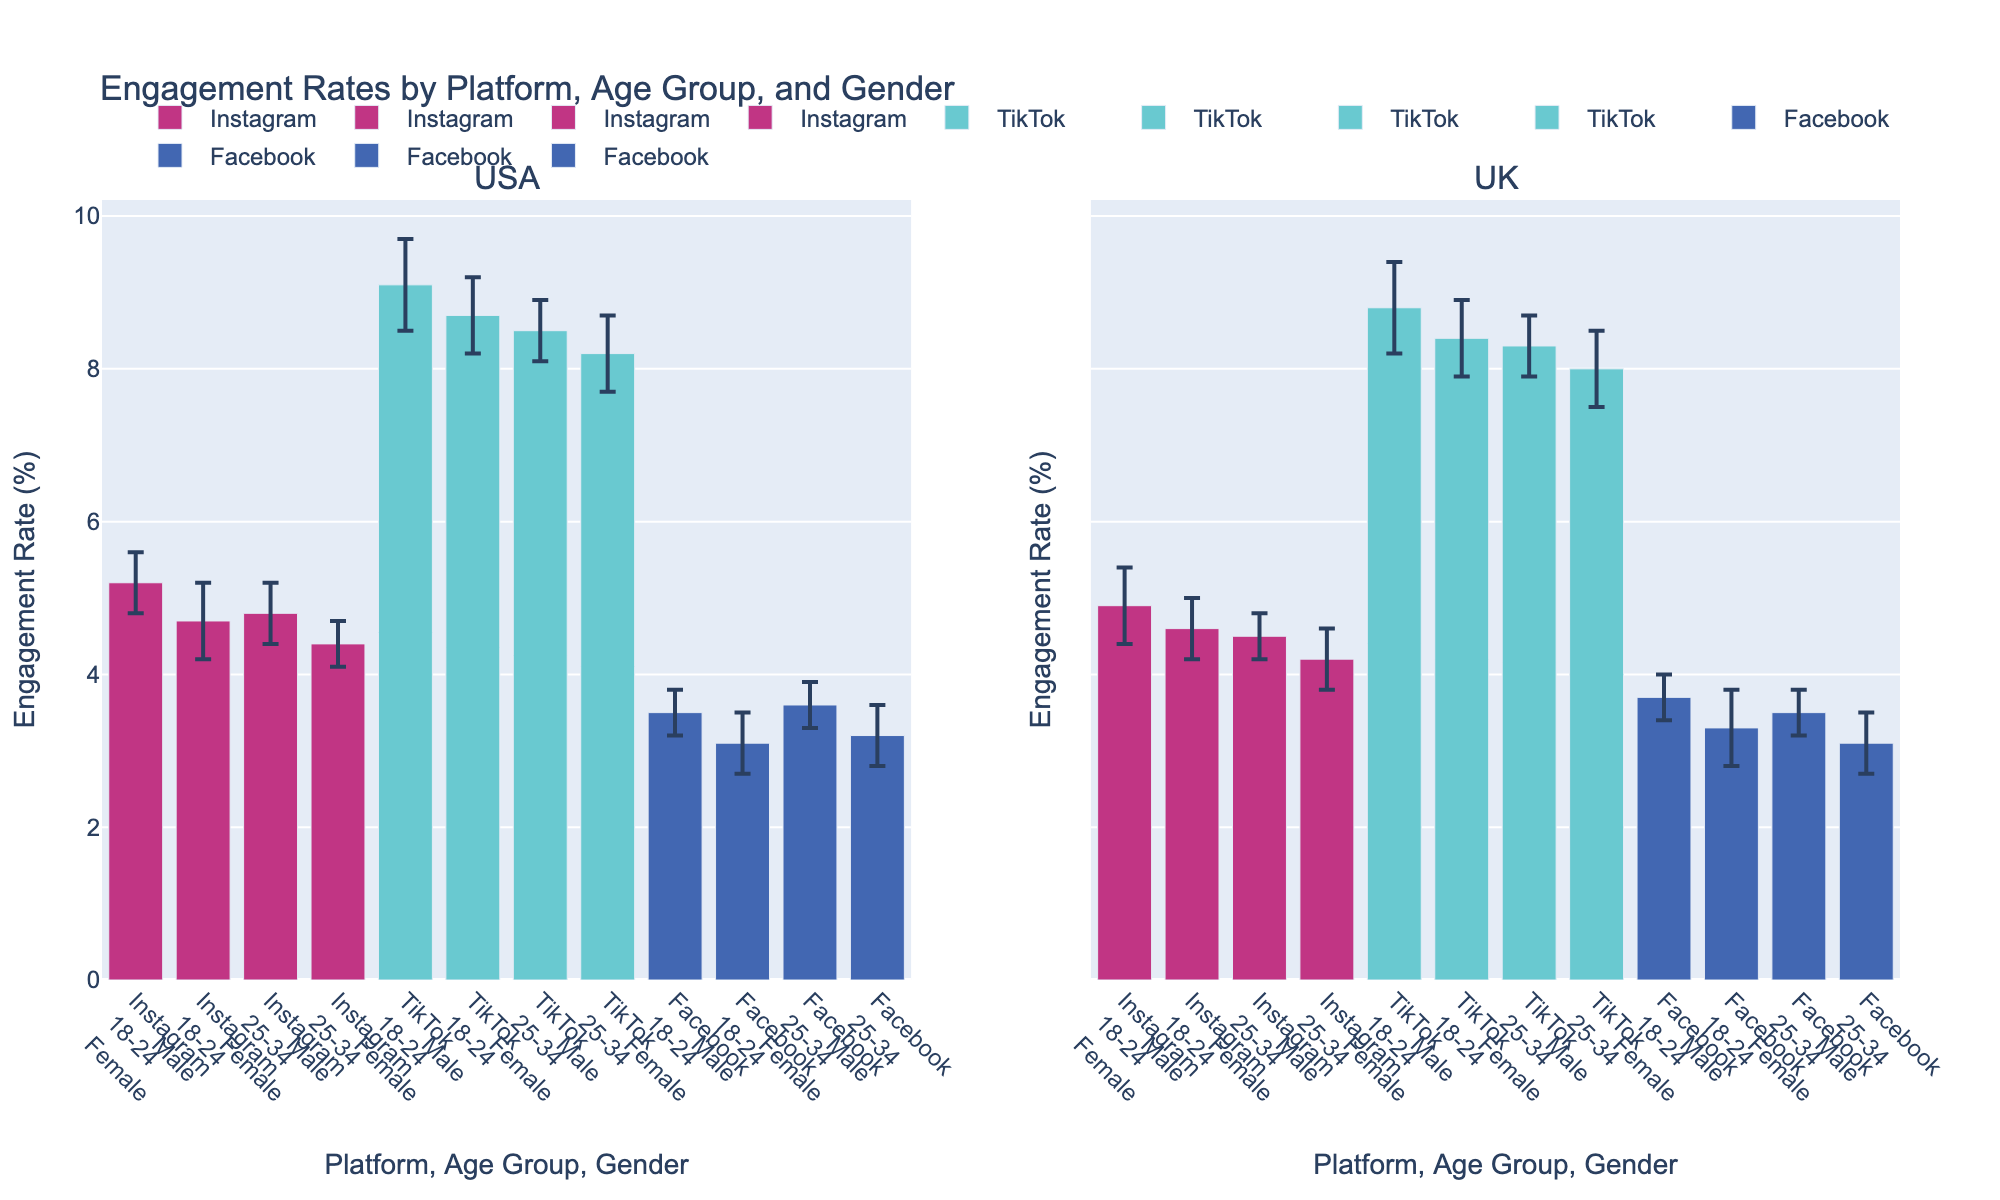what are the social media platforms shown in the figure? The figure has multiple bars grouped by platforms indicated by their unique colors. Observing the legend and bar groupings shows the platforms: Instagram, TikTok, and Facebook.
Answer: Instagram, TikTok, Facebook Which age group and gender in the USA have the highest engagement on Instagram? By looking at the USA section and comparing engagement rates of Instagram bars, the group with the highest rate is 18-24 Females.
Answer: 18-24 Females What’s the difference in TikTok engagement rates between 18-24 females and 25-34 males in the UK? Compare the TikTok bar heights between 18-24 females and 25-34 males in the UK section. The rates are 8.8% and 8.0%, respectively. The difference is 8.8% - 8.0% = 0.8%.
Answer: 0.8% Which platform generally shows higher engagement rates across all demographics, Instagram or TikTok? Inspect and compare overall bar heights for Instagram and TikTok across both the USA and UK sections. TikTok consistently has higher engagement rates than Instagram.
Answer: TikTok What is the lowest engagement rate for Facebook in the UK, and which demographic does it correspond to? In the UK section for Facebook, the lowest bar corresponds to 25-34 Males, showing an engagement rate of 3.1%.
Answer: 3.1%, 25-34 Males How does the engagement rate of 25-34 female users on Facebook in the UK compare to those on TikTok in the USA? Compare the 25-34 female Facebook bar in the UK (3.5%) and 25-34 female TikTok bar in the USA (8.5%). TikTok users have a notably higher engagement rate.
Answer: TikTok is higher What are the error margins for 18-24 males using Facebook in the USA and UK? Are they the same? Error margins are visually represented by the error bars. Compare the lengths of error bars for 18-24 males on Facebook in both USA (0.4) and UK (0.5). They differ.
Answer: No Which platform, gender, and age group combination has the smallest error margin? Look across all groups for the shortest error bar. The smallest one belongs to Instagram 25-34 Males in the USA, with an error margin of 0.3%.
Answer: Instagram 25-34 Males, USA, 0.3% Is there a significant difference between TikTok engagement rates for 18-24 males in the USA and UK? Compare the bar heights for TikTok 18-24 males in both sections. USA has 8.7% and UK has 8.4%. The difference is 8.7% - 8.4% = 0.3%, a relatively small difference visually.
Answer: No significant difference 